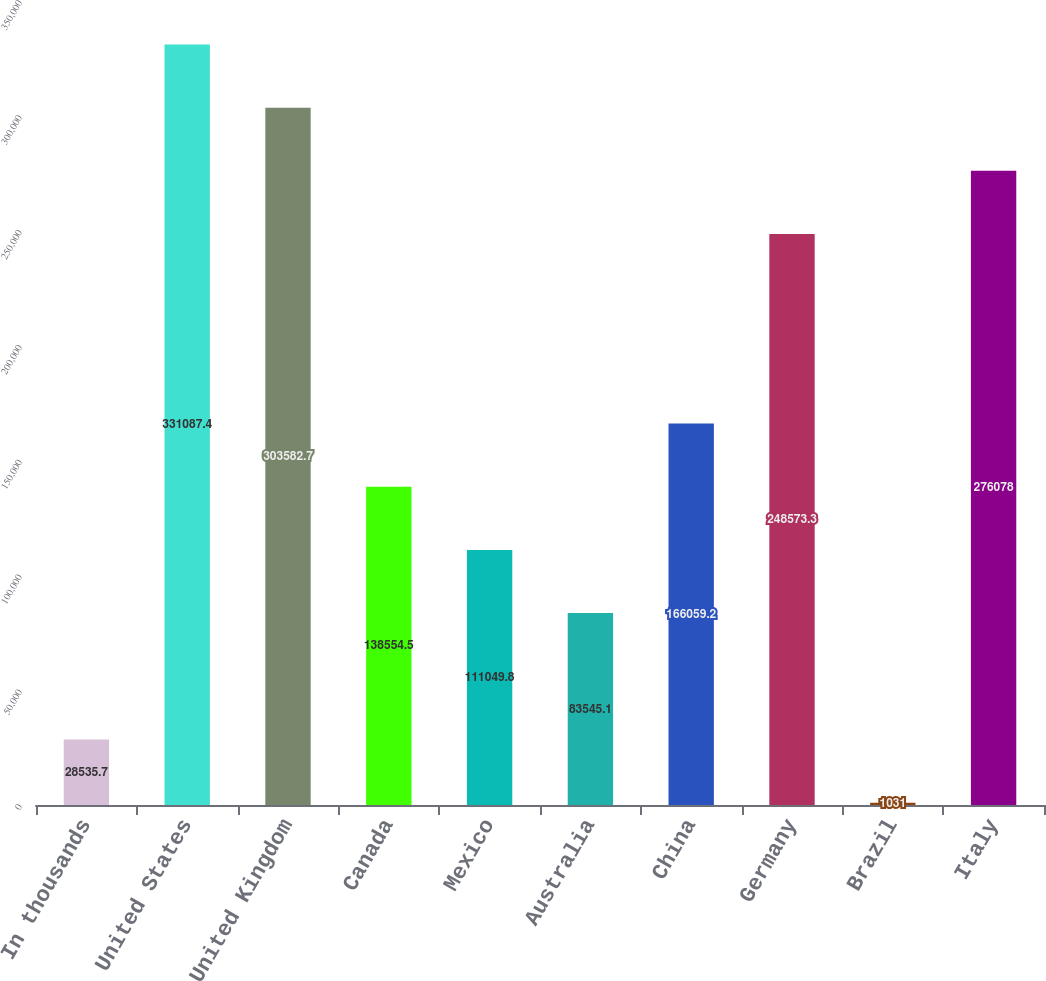Convert chart. <chart><loc_0><loc_0><loc_500><loc_500><bar_chart><fcel>In thousands<fcel>United States<fcel>United Kingdom<fcel>Canada<fcel>Mexico<fcel>Australia<fcel>China<fcel>Germany<fcel>Brazil<fcel>Italy<nl><fcel>28535.7<fcel>331087<fcel>303583<fcel>138554<fcel>111050<fcel>83545.1<fcel>166059<fcel>248573<fcel>1031<fcel>276078<nl></chart> 